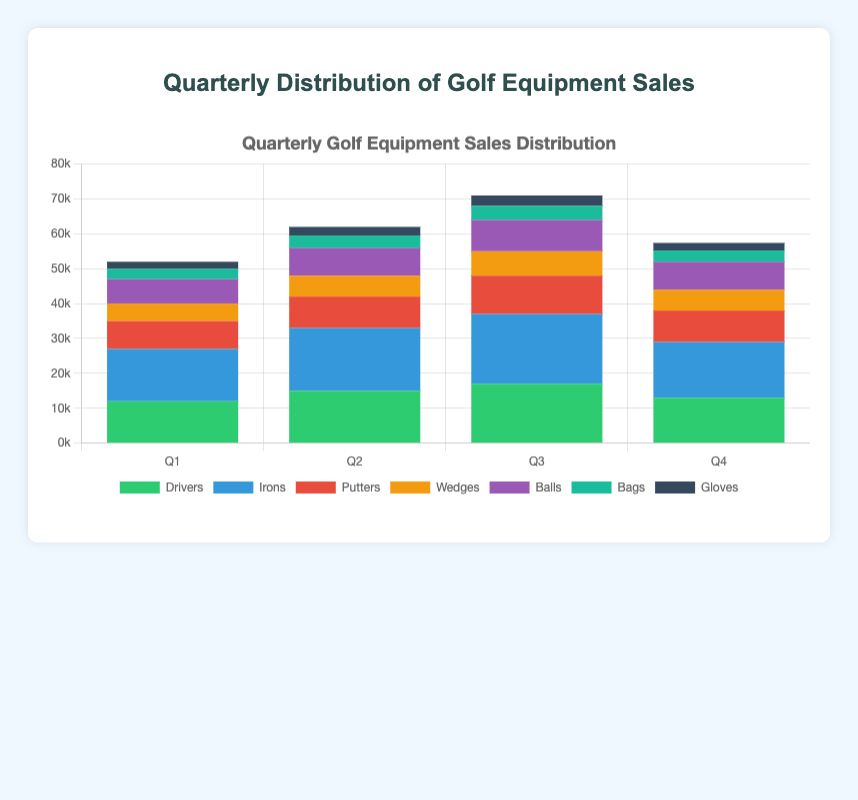Which quarter has the highest total sales for drivers? Look at the "Drivers" bars in each quarter. The height of the bar for Q3 is the tallest among all quarters.
Answer: Q3 What is the total sales amount for Irons in Q1 and Q2 combined? Add the sales figures for Irons in Q1 and Q2: 15000 (Q1) + 18000 (Q2) = 33000.
Answer: 33000 In which quarter are glove sales the lowest? Compare the "Gloves" bar for each quarter. The shortest bar is in Q1.
Answer: Q1 How much greater are the sales of putters in Q3 compared to Q1? Find the difference: 11000 (Q3) - 8000 (Q1) = 3000.
Answer: 3000 Which type of equipment has the highest sales in Q4? Look at the highest bar in Q4; it corresponds to Irons.
Answer: Irons What is the combined sales of bags and gloves in Q2? Add the sales for Bags and Gloves in Q2: 3500 (Bags) + 2500 (Gloves) = 6000.
Answer: 6000 Are the sales of Balls in Q3 greater than the sales of Balls and Gloves combined in Q4? Compare the sums: 9000 (Balls, Q3) to 8000 + 2200 (Balls + Gloves, Q4) = 10200.
Answer: No Which quarter has the lowest total sales for wedges? Compare the height of the "Wedges" bar for each quarter. The bar for Q1 is the shortest.
Answer: Q1 What is the difference in sales between Drivers and Irons in Q1? Find the difference: 15000 (Irons) - 12000 (Drivers) = 3000.
Answer: 3000 Is the sales trend for Irons increasing or decreasing over the quarters? Observe the "Irons" bars from Q1 to Q4: 15000 -> 18000 -> 20000 -> 16000. The trend increases from Q1 to Q3, then decreases in Q4.
Answer: Increasing then decreasing 